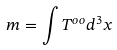<formula> <loc_0><loc_0><loc_500><loc_500>m = \int T ^ { o o } d ^ { 3 } x</formula> 